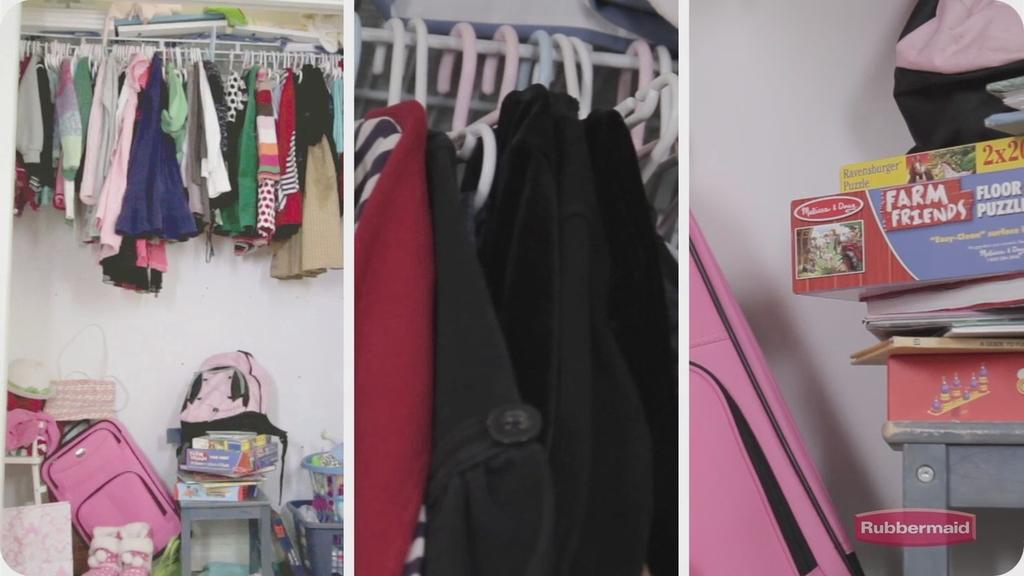<image>
Write a terse but informative summary of the picture. A game called Farm Friends is stacked on a closet shelf. 